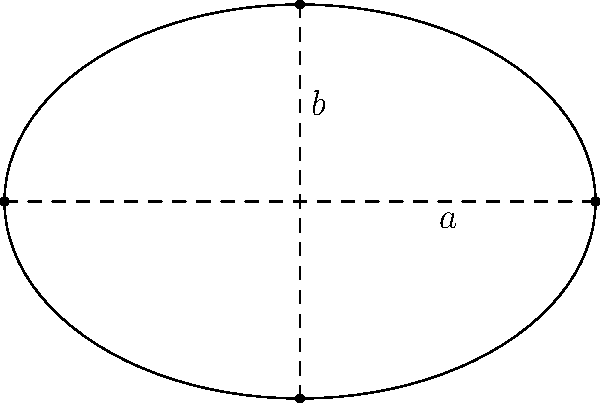Consider an ellipse with semi-major axis $a$ and semi-minor axis $b$. The eccentricity of the ellipse is given by $e = \sqrt{1 - \frac{b^2}{a^2}}$. Ramanujan's approximation for the perimeter of an ellipse is:

$$P \approx \pi(a+b)\left(1 + \frac{3h}{10 + \sqrt{4-3h}}\right)$$

where $h = \frac{(a-b)^2}{(a+b)^2}$.

Prove that as the eccentricity $e$ approaches 0 (i.e., the ellipse becomes more circular), Ramanujan's approximation converges to the exact formula for the circumference of a circle. What philosophical implications does this have on the nature of mathematical approximations? Let's approach this proof step-by-step:

1) As $e$ approaches 0, $b$ approaches $a$. This means the ellipse is becoming more circular.

2) When $b = a$, we have a circle with radius $r = a = b$.

3) Let's examine what happens to $h$ as $b$ approaches $a$:
   
   $h = \frac{(a-b)^2}{(a+b)^2} \to \frac{(a-a)^2}{(a+a)^2} = \frac{0^2}{(2a)^2} = 0$

4) Now, let's substitute $h = 0$ into Ramanujan's approximation:

   $P \approx \pi(a+a)\left(1 + \frac{3(0)}{10 + \sqrt{4-3(0)}}\right)$
   
   $= 2\pi a \left(1 + \frac{0}{10 + 2}\right) = 2\pi a$

5) This is exactly the formula for the circumference of a circle with radius $a$.

Philosophical implications:
1) This convergence demonstrates the continuity between different mathematical concepts (ellipse and circle).
2) It shows how approximations can capture fundamental truths about mathematical objects.
3) It illustrates the power of limits in mathematics to bridge between different formulas and concepts.
4) This example highlights how mathematical approximations can be exact in limiting cases, blurring the line between approximation and exact calculation.
5) It raises questions about the nature of mathematical truth: Is an approximation that becomes exact in a limit fundamentally different from an exact formula?
Answer: As $e \to 0$, Ramanujan's approximation $\to 2\pi a$, the exact circle circumference. 